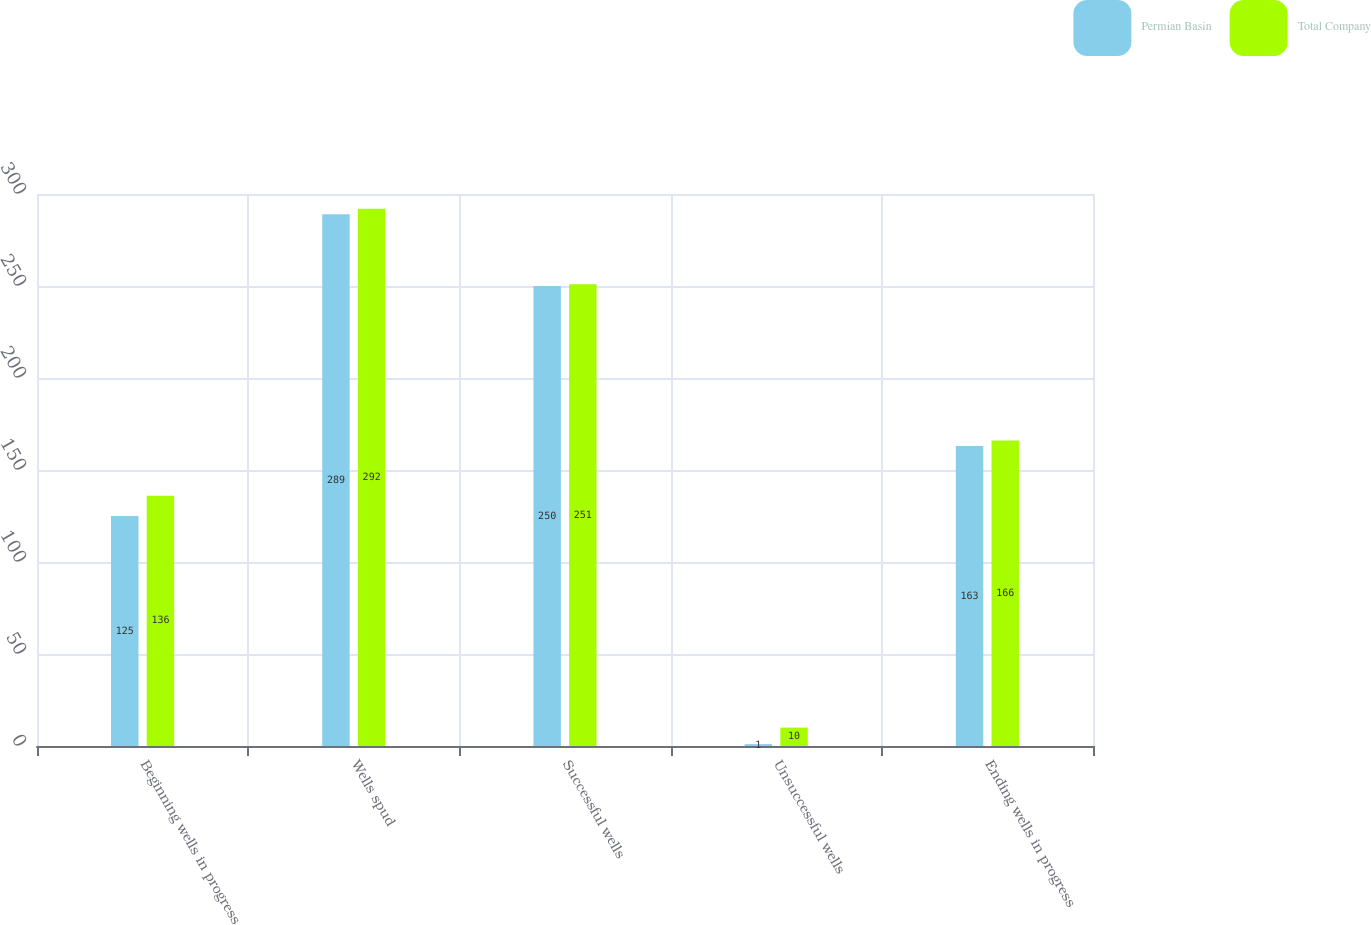<chart> <loc_0><loc_0><loc_500><loc_500><stacked_bar_chart><ecel><fcel>Beginning wells in progress<fcel>Wells spud<fcel>Successful wells<fcel>Unsuccessful wells<fcel>Ending wells in progress<nl><fcel>Permian Basin<fcel>125<fcel>289<fcel>250<fcel>1<fcel>163<nl><fcel>Total Company<fcel>136<fcel>292<fcel>251<fcel>10<fcel>166<nl></chart> 